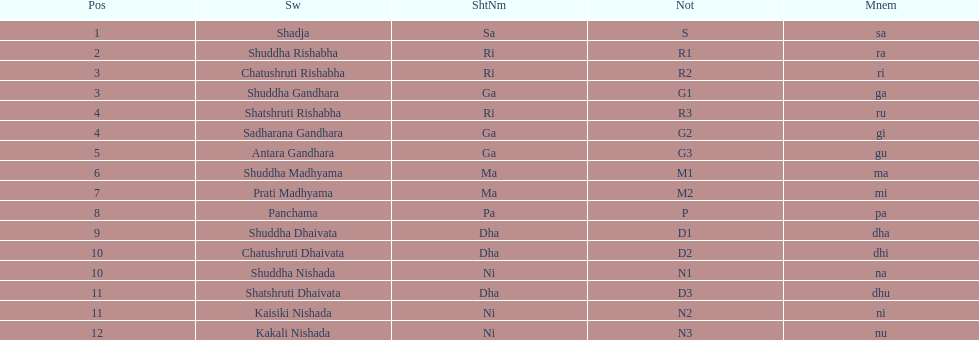How many swaras do not have dhaivata in their name? 13. 